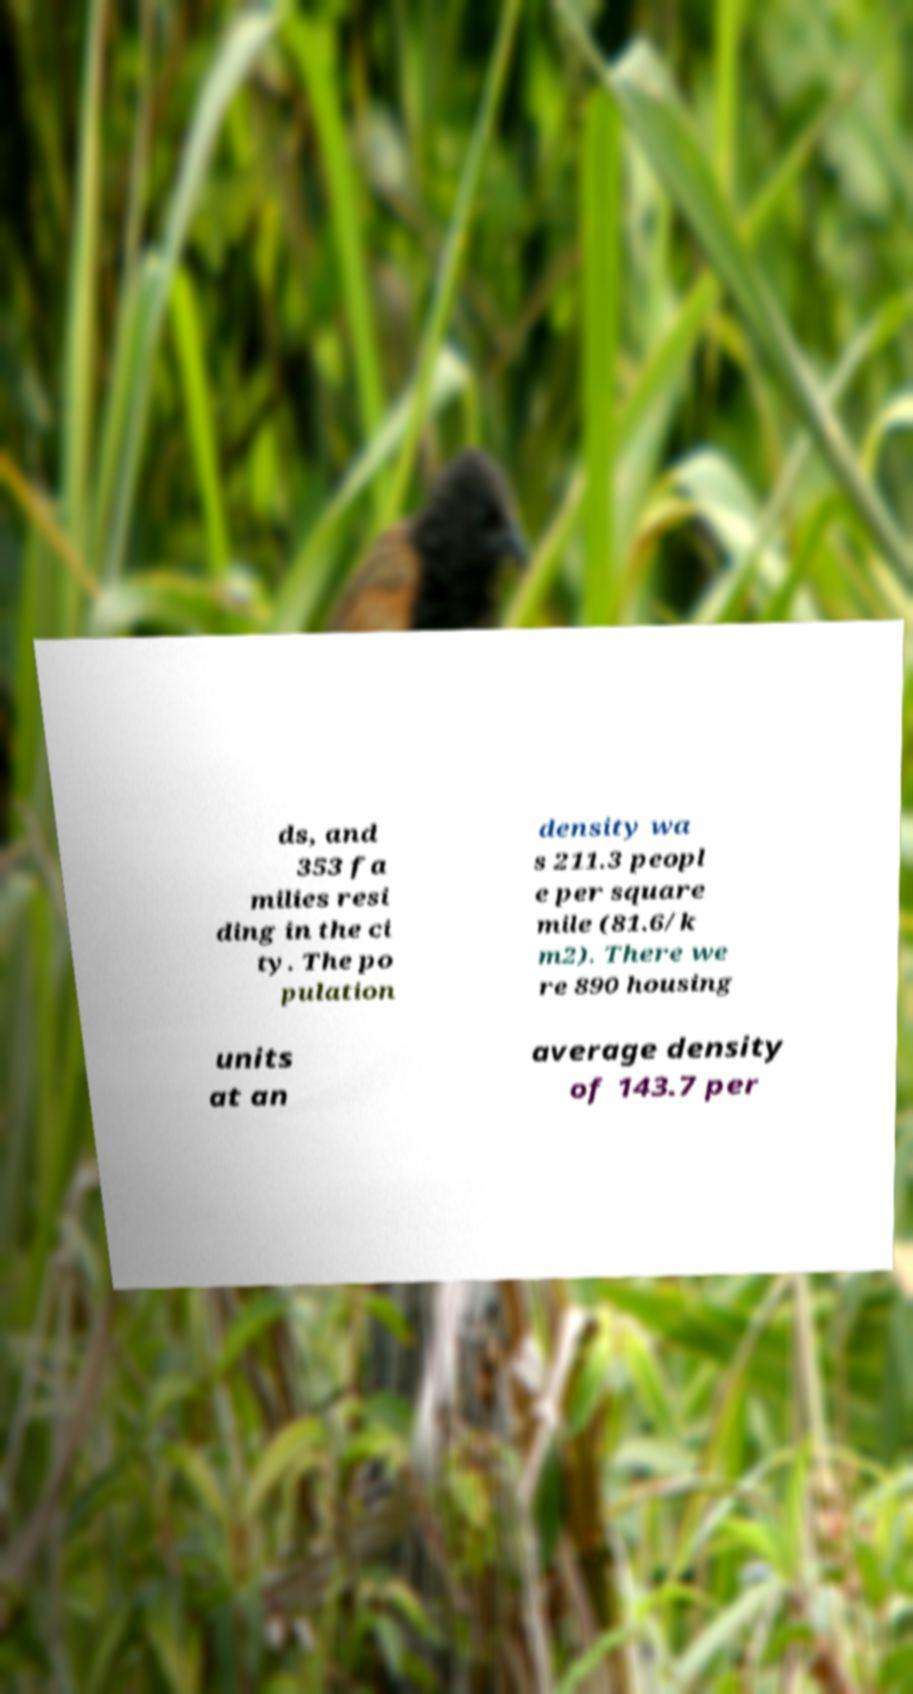Could you assist in decoding the text presented in this image and type it out clearly? ds, and 353 fa milies resi ding in the ci ty. The po pulation density wa s 211.3 peopl e per square mile (81.6/k m2). There we re 890 housing units at an average density of 143.7 per 